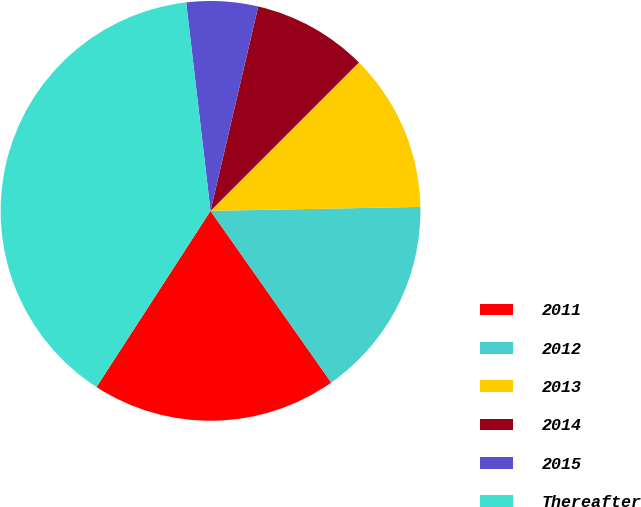Convert chart to OTSL. <chart><loc_0><loc_0><loc_500><loc_500><pie_chart><fcel>2011<fcel>2012<fcel>2013<fcel>2014<fcel>2015<fcel>Thereafter<nl><fcel>18.9%<fcel>15.55%<fcel>12.2%<fcel>8.85%<fcel>5.5%<fcel>39.01%<nl></chart> 